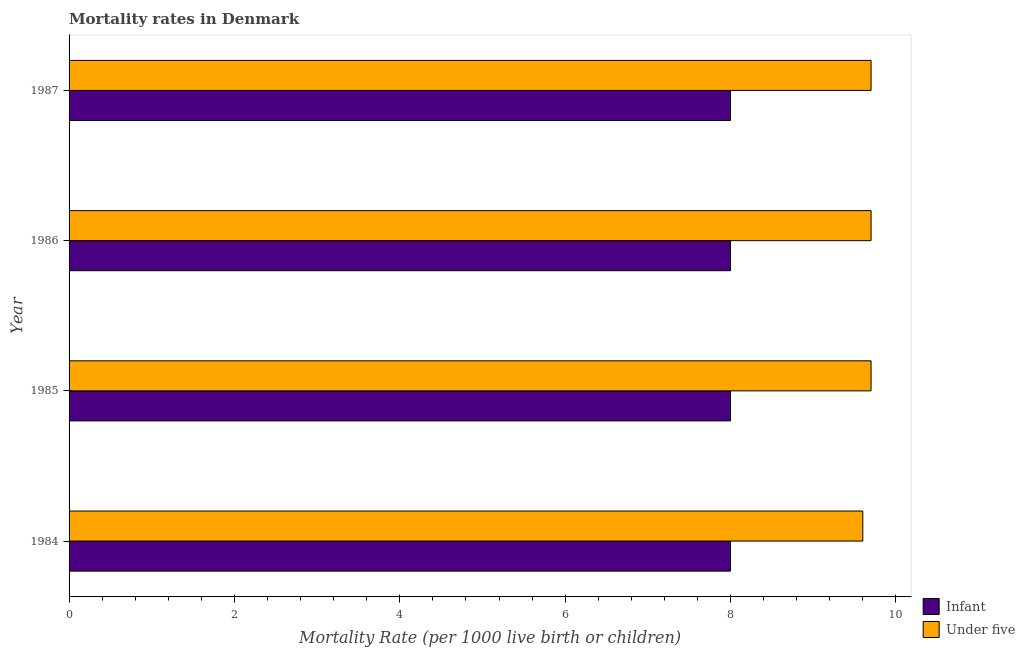How many different coloured bars are there?
Provide a succinct answer. 2. How many groups of bars are there?
Keep it short and to the point. 4. What is the infant mortality rate in 1987?
Your answer should be compact. 8. Across all years, what is the maximum infant mortality rate?
Offer a terse response. 8. Across all years, what is the minimum infant mortality rate?
Your response must be concise. 8. What is the difference between the infant mortality rate in 1985 and the under-5 mortality rate in 1987?
Provide a succinct answer. -1.7. What is the average under-5 mortality rate per year?
Give a very brief answer. 9.68. In the year 1987, what is the difference between the infant mortality rate and under-5 mortality rate?
Provide a short and direct response. -1.7. In how many years, is the infant mortality rate greater than 6.8 ?
Offer a very short reply. 4. Is the infant mortality rate in 1984 less than that in 1987?
Provide a succinct answer. No. What is the difference between the highest and the second highest under-5 mortality rate?
Keep it short and to the point. 0. In how many years, is the under-5 mortality rate greater than the average under-5 mortality rate taken over all years?
Offer a very short reply. 3. What does the 2nd bar from the top in 1986 represents?
Keep it short and to the point. Infant. What does the 2nd bar from the bottom in 1987 represents?
Offer a very short reply. Under five. Are the values on the major ticks of X-axis written in scientific E-notation?
Offer a terse response. No. Does the graph contain any zero values?
Offer a very short reply. No. Where does the legend appear in the graph?
Your answer should be very brief. Bottom right. How many legend labels are there?
Offer a very short reply. 2. How are the legend labels stacked?
Your response must be concise. Vertical. What is the title of the graph?
Offer a very short reply. Mortality rates in Denmark. What is the label or title of the X-axis?
Keep it short and to the point. Mortality Rate (per 1000 live birth or children). What is the Mortality Rate (per 1000 live birth or children) in Infant in 1984?
Your response must be concise. 8. What is the Mortality Rate (per 1000 live birth or children) of Under five in 1984?
Keep it short and to the point. 9.6. What is the Mortality Rate (per 1000 live birth or children) of Infant in 1985?
Your answer should be very brief. 8. What is the Mortality Rate (per 1000 live birth or children) of Under five in 1986?
Your answer should be very brief. 9.7. What is the Mortality Rate (per 1000 live birth or children) in Under five in 1987?
Ensure brevity in your answer.  9.7. Across all years, what is the minimum Mortality Rate (per 1000 live birth or children) of Under five?
Offer a terse response. 9.6. What is the total Mortality Rate (per 1000 live birth or children) of Infant in the graph?
Your answer should be compact. 32. What is the total Mortality Rate (per 1000 live birth or children) in Under five in the graph?
Your response must be concise. 38.7. What is the difference between the Mortality Rate (per 1000 live birth or children) of Under five in 1984 and that in 1985?
Ensure brevity in your answer.  -0.1. What is the difference between the Mortality Rate (per 1000 live birth or children) of Under five in 1985 and that in 1986?
Your answer should be compact. 0. What is the difference between the Mortality Rate (per 1000 live birth or children) of Under five in 1985 and that in 1987?
Ensure brevity in your answer.  0. What is the difference between the Mortality Rate (per 1000 live birth or children) in Infant in 1986 and that in 1987?
Ensure brevity in your answer.  0. What is the difference between the Mortality Rate (per 1000 live birth or children) of Under five in 1986 and that in 1987?
Provide a succinct answer. 0. What is the difference between the Mortality Rate (per 1000 live birth or children) of Infant in 1985 and the Mortality Rate (per 1000 live birth or children) of Under five in 1986?
Make the answer very short. -1.7. What is the difference between the Mortality Rate (per 1000 live birth or children) in Infant in 1986 and the Mortality Rate (per 1000 live birth or children) in Under five in 1987?
Provide a succinct answer. -1.7. What is the average Mortality Rate (per 1000 live birth or children) in Infant per year?
Your answer should be compact. 8. What is the average Mortality Rate (per 1000 live birth or children) in Under five per year?
Keep it short and to the point. 9.68. In the year 1984, what is the difference between the Mortality Rate (per 1000 live birth or children) of Infant and Mortality Rate (per 1000 live birth or children) of Under five?
Offer a very short reply. -1.6. In the year 1985, what is the difference between the Mortality Rate (per 1000 live birth or children) of Infant and Mortality Rate (per 1000 live birth or children) of Under five?
Provide a succinct answer. -1.7. In the year 1986, what is the difference between the Mortality Rate (per 1000 live birth or children) of Infant and Mortality Rate (per 1000 live birth or children) of Under five?
Ensure brevity in your answer.  -1.7. What is the ratio of the Mortality Rate (per 1000 live birth or children) of Under five in 1984 to that in 1985?
Provide a succinct answer. 0.99. What is the ratio of the Mortality Rate (per 1000 live birth or children) in Infant in 1984 to that in 1987?
Your answer should be very brief. 1. What is the ratio of the Mortality Rate (per 1000 live birth or children) of Under five in 1984 to that in 1987?
Provide a short and direct response. 0.99. What is the ratio of the Mortality Rate (per 1000 live birth or children) of Under five in 1985 to that in 1986?
Your response must be concise. 1. What is the ratio of the Mortality Rate (per 1000 live birth or children) of Infant in 1985 to that in 1987?
Your answer should be compact. 1. What is the ratio of the Mortality Rate (per 1000 live birth or children) of Under five in 1985 to that in 1987?
Keep it short and to the point. 1. What is the difference between the highest and the lowest Mortality Rate (per 1000 live birth or children) in Infant?
Make the answer very short. 0. What is the difference between the highest and the lowest Mortality Rate (per 1000 live birth or children) of Under five?
Ensure brevity in your answer.  0.1. 